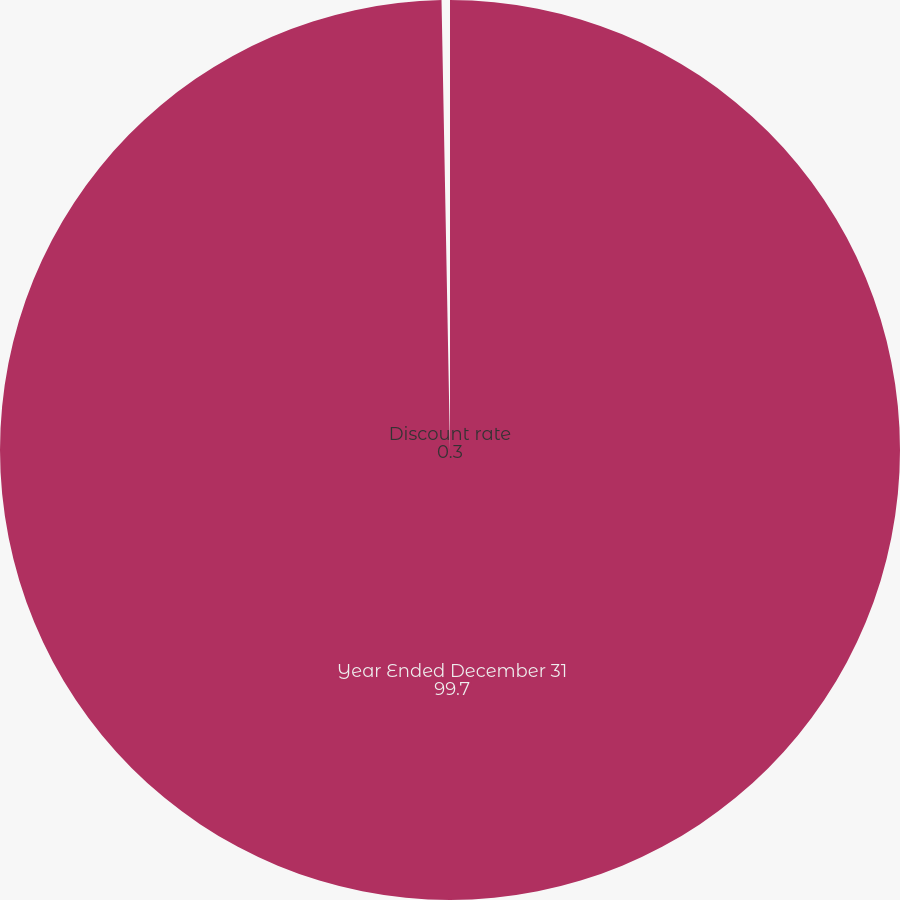<chart> <loc_0><loc_0><loc_500><loc_500><pie_chart><fcel>Year Ended December 31<fcel>Discount rate<nl><fcel>99.7%<fcel>0.3%<nl></chart> 